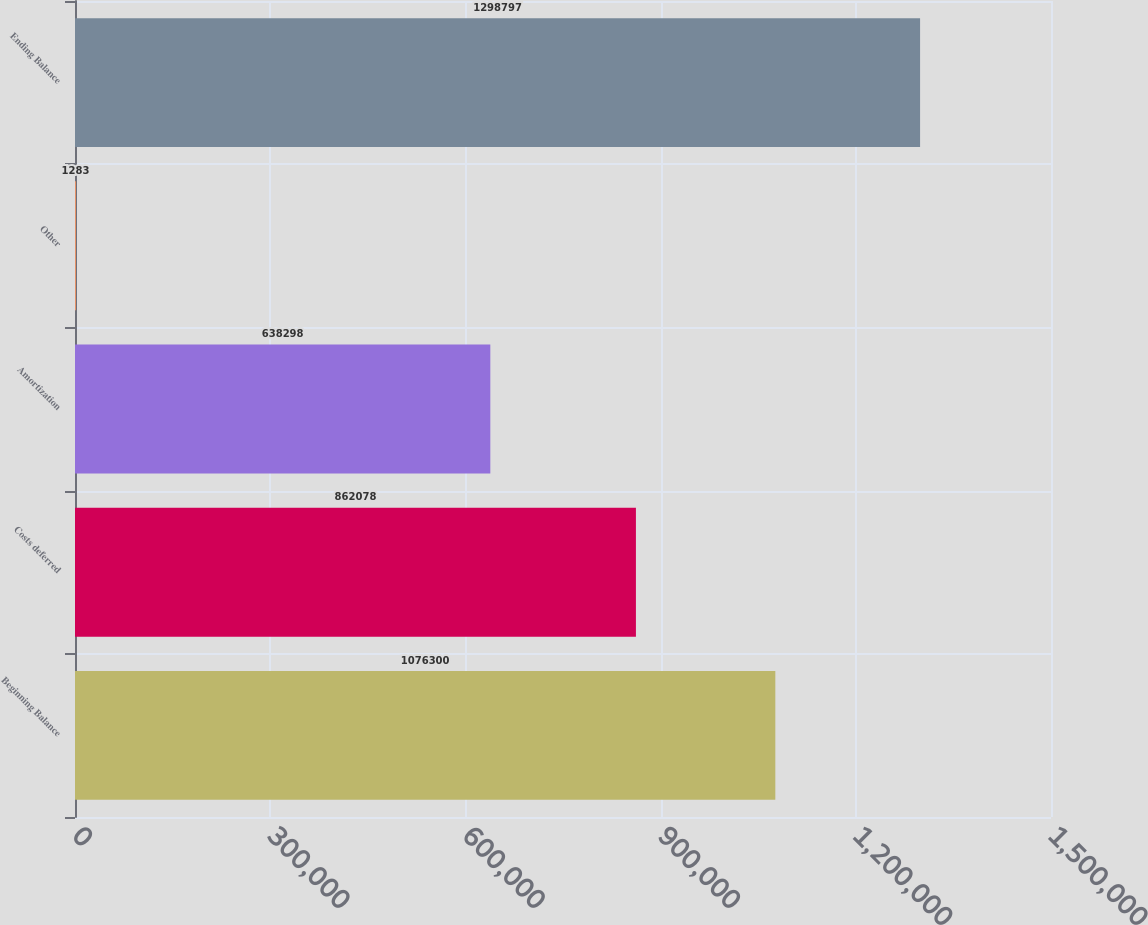<chart> <loc_0><loc_0><loc_500><loc_500><bar_chart><fcel>Beginning Balance<fcel>Costs deferred<fcel>Amortization<fcel>Other<fcel>Ending Balance<nl><fcel>1.0763e+06<fcel>862078<fcel>638298<fcel>1283<fcel>1.2988e+06<nl></chart> 